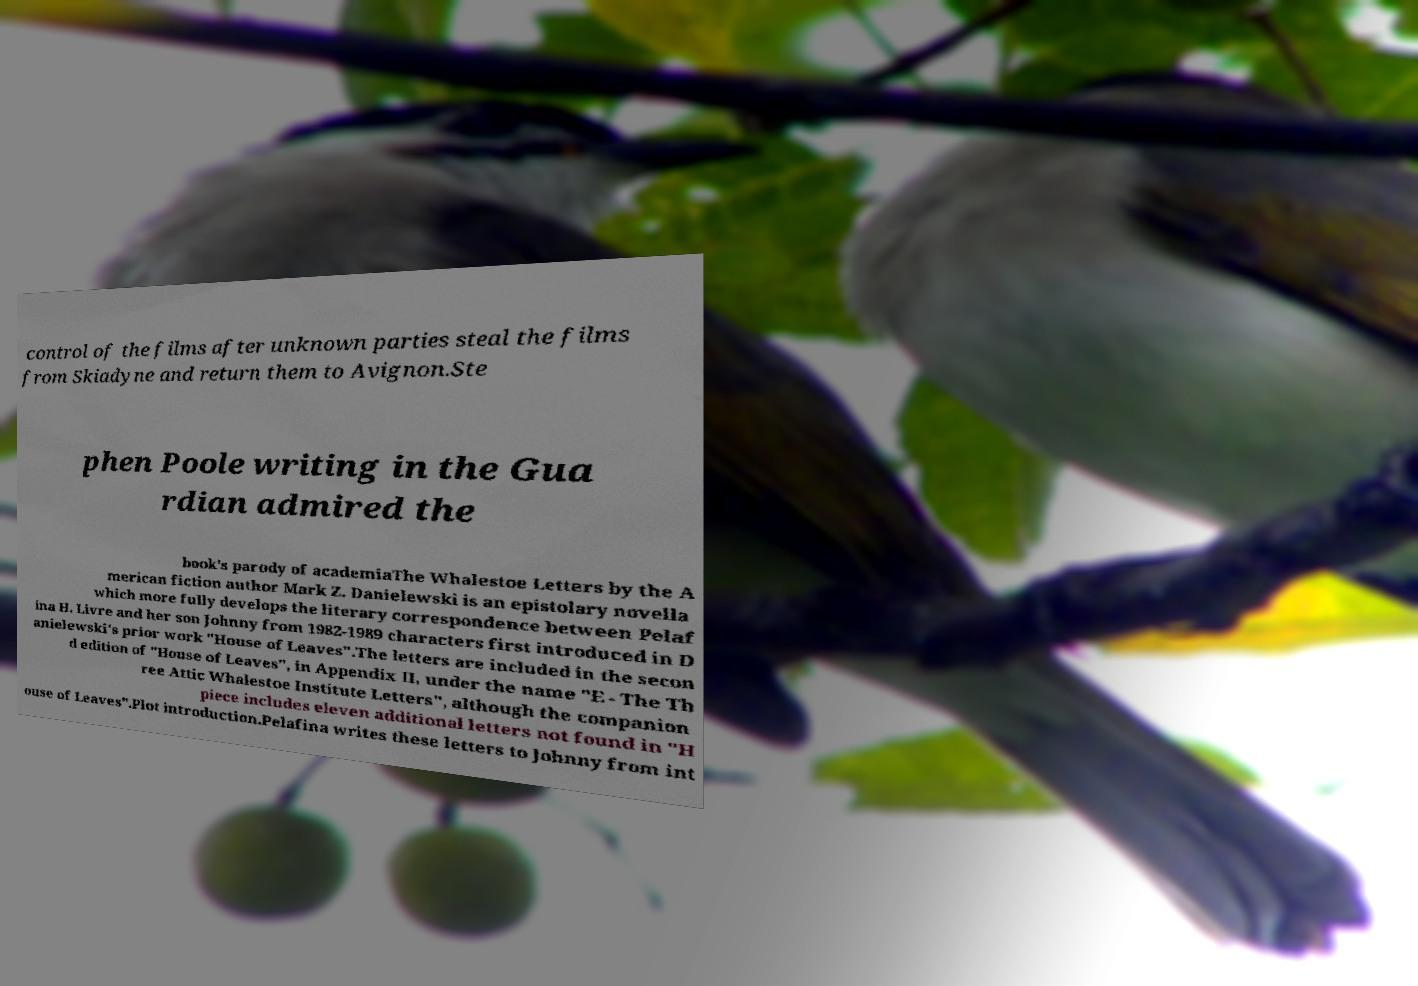Please identify and transcribe the text found in this image. control of the films after unknown parties steal the films from Skiadyne and return them to Avignon.Ste phen Poole writing in the Gua rdian admired the book's parody of academiaThe Whalestoe Letters by the A merican fiction author Mark Z. Danielewski is an epistolary novella which more fully develops the literary correspondence between Pelaf ina H. Livre and her son Johnny from 1982-1989 characters first introduced in D anielewski's prior work "House of Leaves".The letters are included in the secon d edition of "House of Leaves", in Appendix II, under the name "E - The Th ree Attic Whalestoe Institute Letters", although the companion piece includes eleven additional letters not found in "H ouse of Leaves".Plot introduction.Pelafina writes these letters to Johnny from int 